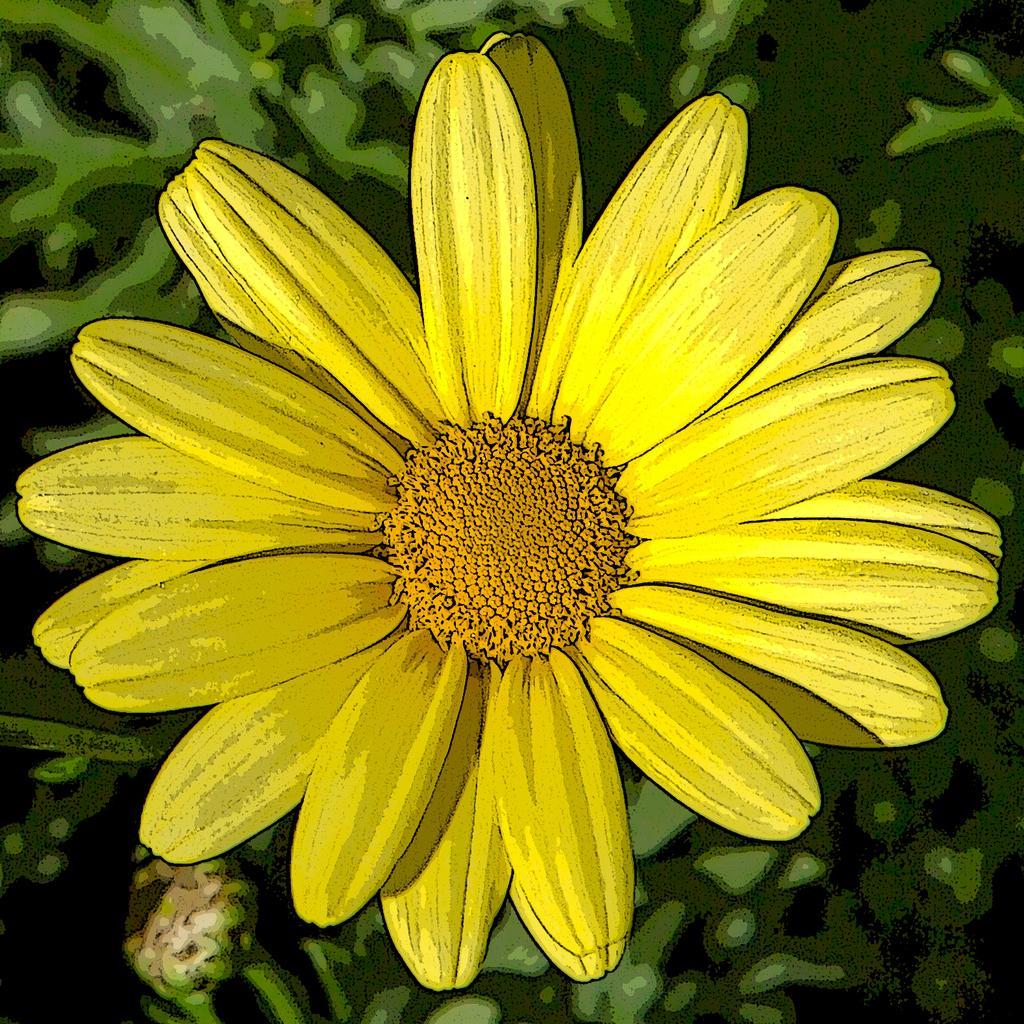Could you give a brief overview of what you see in this image? In this picture I see a yellow color flower and few plants and the picture looks like a painting. 